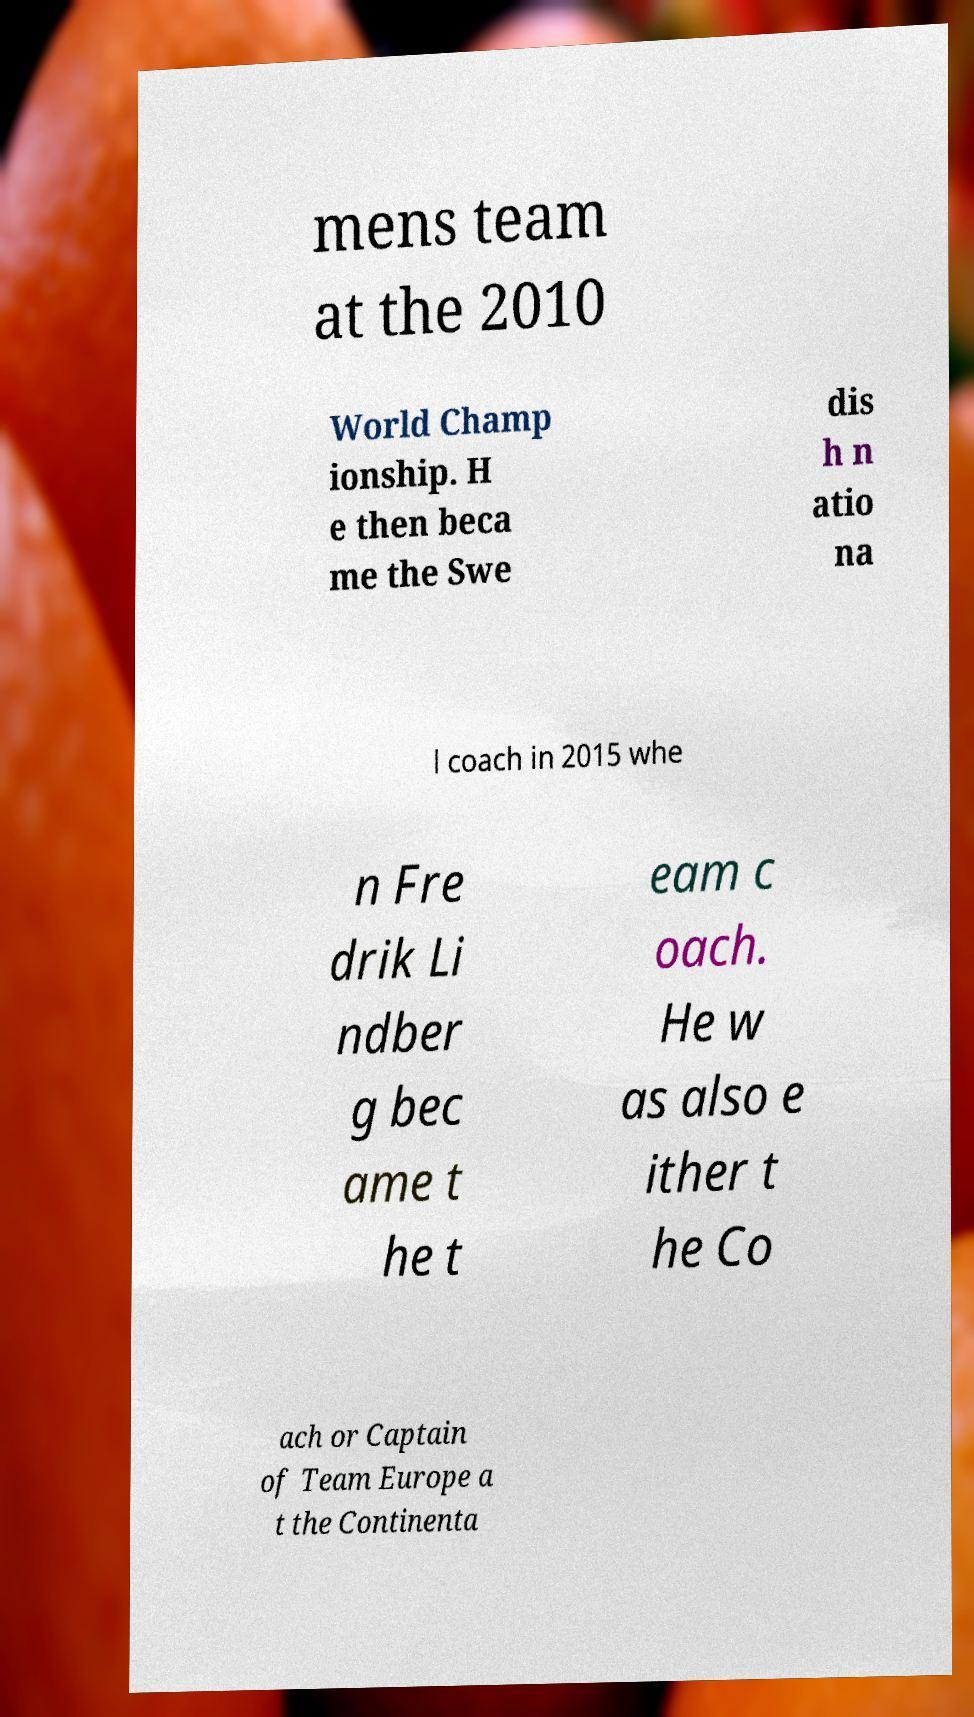What messages or text are displayed in this image? I need them in a readable, typed format. mens team at the 2010 World Champ ionship. H e then beca me the Swe dis h n atio na l coach in 2015 whe n Fre drik Li ndber g bec ame t he t eam c oach. He w as also e ither t he Co ach or Captain of Team Europe a t the Continenta 